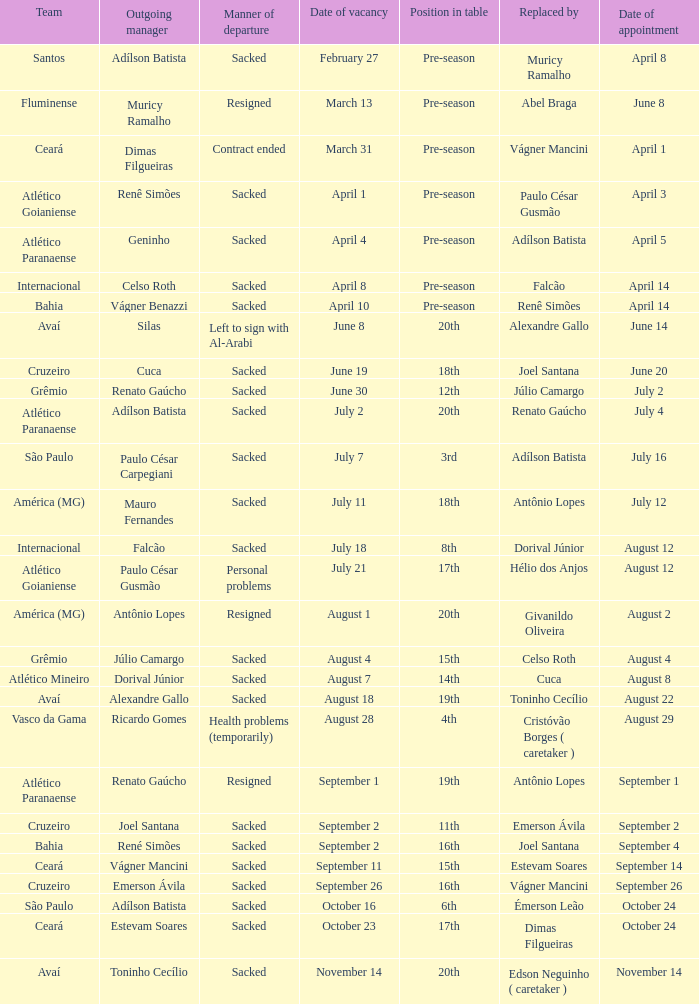What squad recruited renato gaúcho? Atlético Paranaense. 